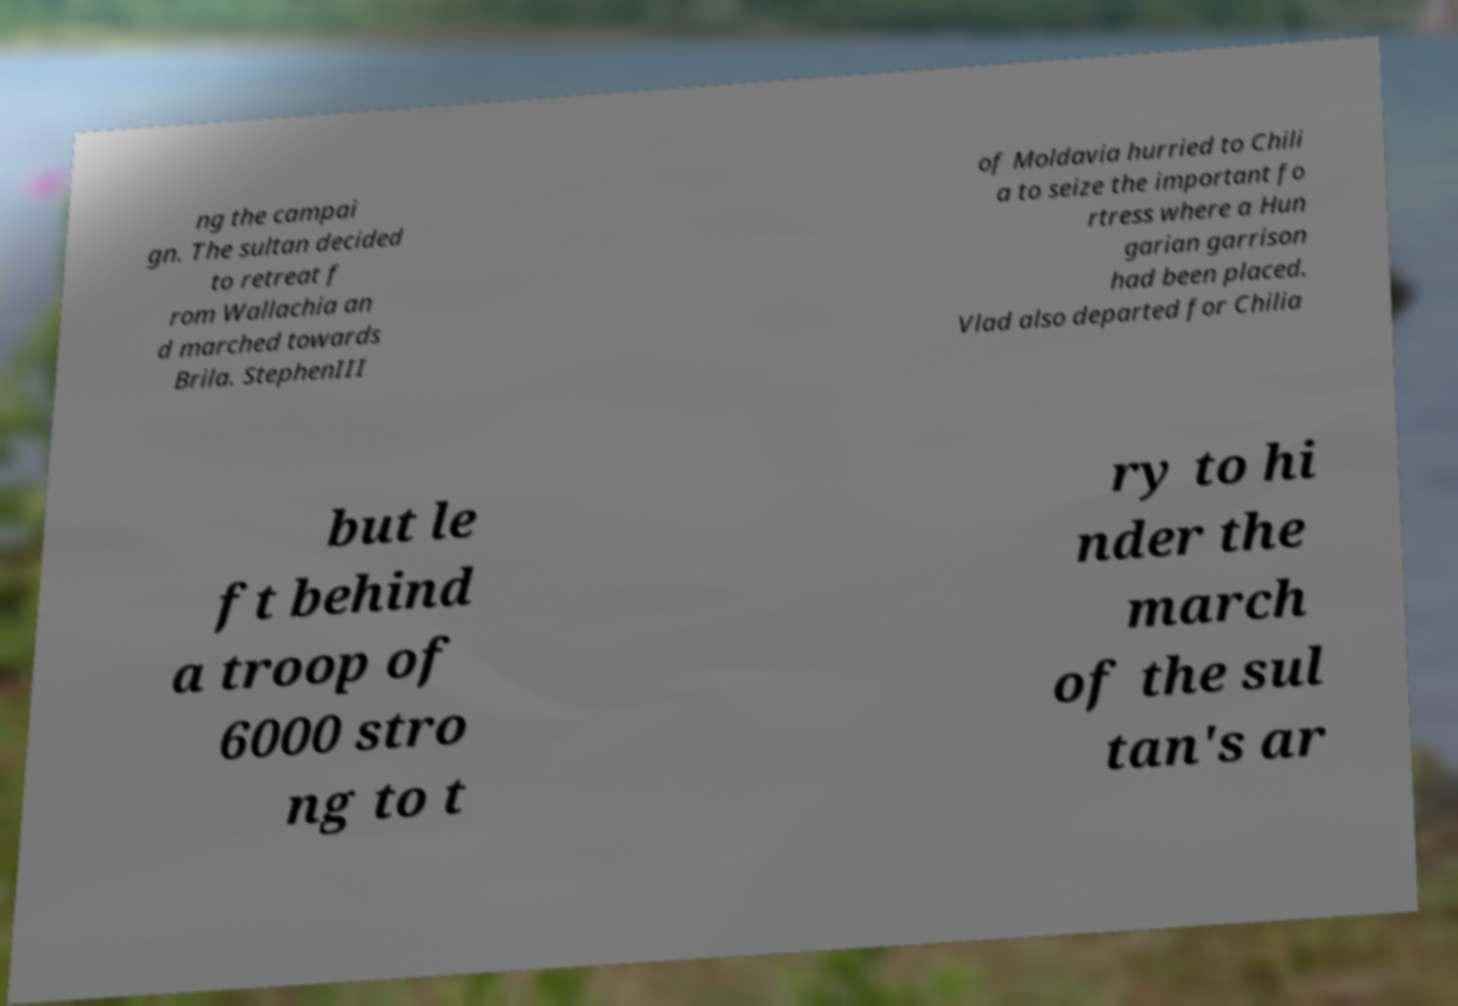Please read and relay the text visible in this image. What does it say? ng the campai gn. The sultan decided to retreat f rom Wallachia an d marched towards Brila. StephenIII of Moldavia hurried to Chili a to seize the important fo rtress where a Hun garian garrison had been placed. Vlad also departed for Chilia but le ft behind a troop of 6000 stro ng to t ry to hi nder the march of the sul tan's ar 